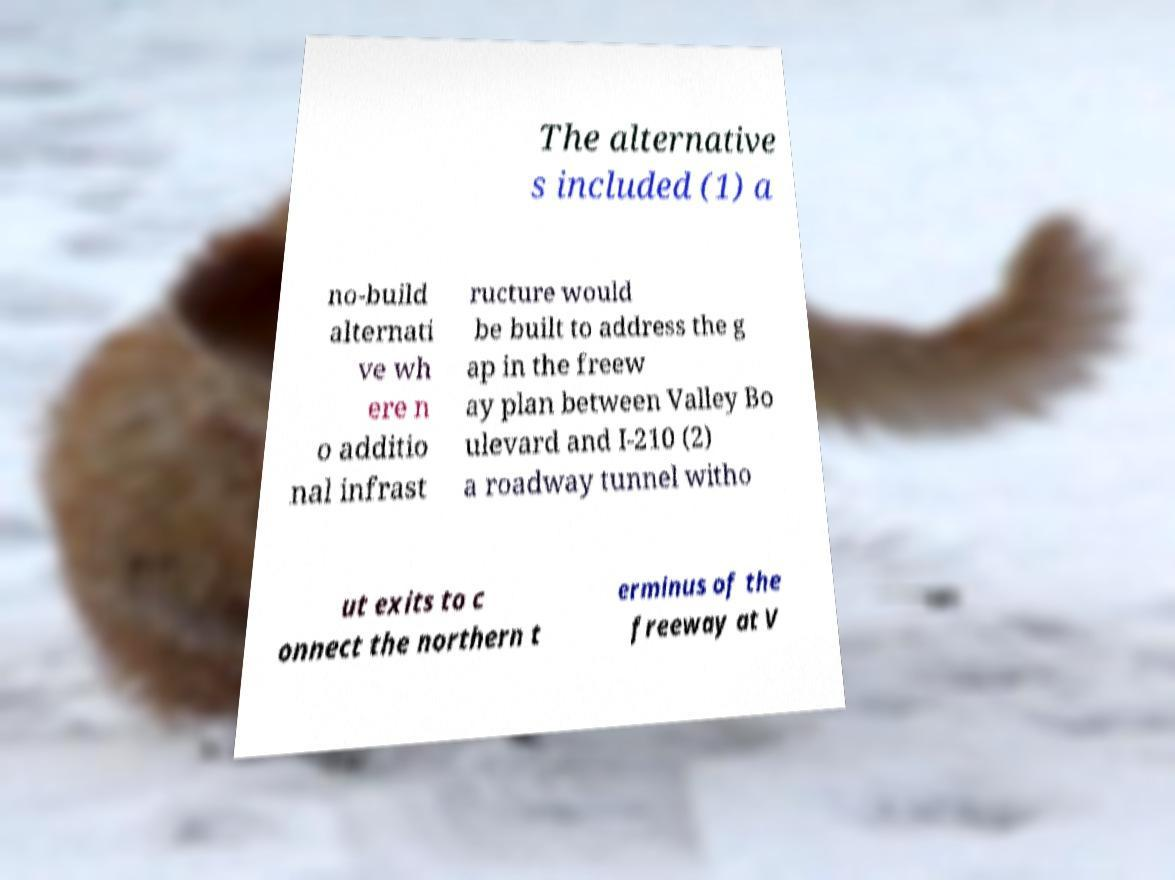I need the written content from this picture converted into text. Can you do that? The alternative s included (1) a no-build alternati ve wh ere n o additio nal infrast ructure would be built to address the g ap in the freew ay plan between Valley Bo ulevard and I-210 (2) a roadway tunnel witho ut exits to c onnect the northern t erminus of the freeway at V 